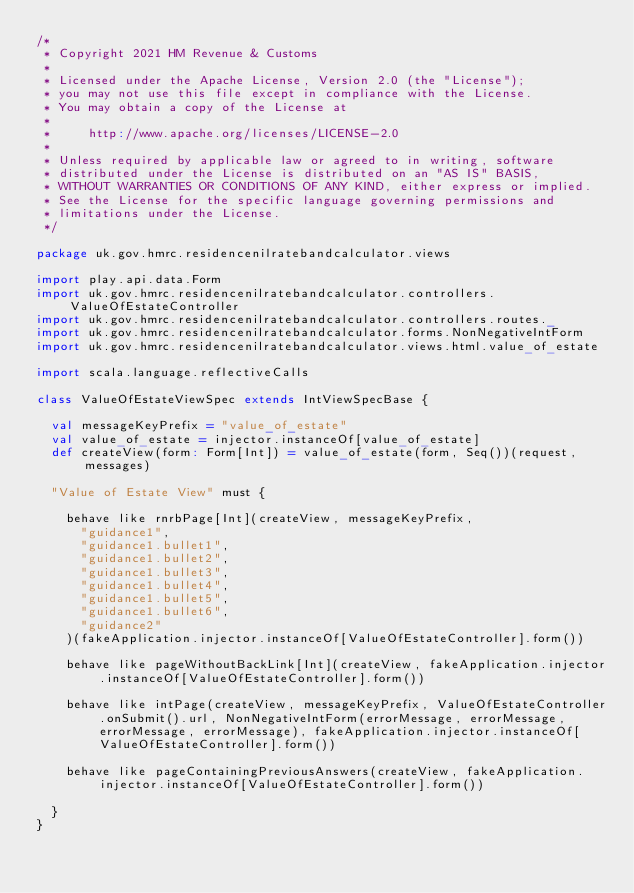Convert code to text. <code><loc_0><loc_0><loc_500><loc_500><_Scala_>/*
 * Copyright 2021 HM Revenue & Customs
 *
 * Licensed under the Apache License, Version 2.0 (the "License");
 * you may not use this file except in compliance with the License.
 * You may obtain a copy of the License at
 *
 *     http://www.apache.org/licenses/LICENSE-2.0
 *
 * Unless required by applicable law or agreed to in writing, software
 * distributed under the License is distributed on an "AS IS" BASIS,
 * WITHOUT WARRANTIES OR CONDITIONS OF ANY KIND, either express or implied.
 * See the License for the specific language governing permissions and
 * limitations under the License.
 */

package uk.gov.hmrc.residencenilratebandcalculator.views

import play.api.data.Form
import uk.gov.hmrc.residencenilratebandcalculator.controllers.ValueOfEstateController
import uk.gov.hmrc.residencenilratebandcalculator.controllers.routes._
import uk.gov.hmrc.residencenilratebandcalculator.forms.NonNegativeIntForm
import uk.gov.hmrc.residencenilratebandcalculator.views.html.value_of_estate

import scala.language.reflectiveCalls

class ValueOfEstateViewSpec extends IntViewSpecBase {

  val messageKeyPrefix = "value_of_estate"
  val value_of_estate = injector.instanceOf[value_of_estate]
  def createView(form: Form[Int]) = value_of_estate(form, Seq())(request, messages)

  "Value of Estate View" must {

    behave like rnrbPage[Int](createView, messageKeyPrefix,
      "guidance1",
      "guidance1.bullet1",
      "guidance1.bullet2",
      "guidance1.bullet3",
      "guidance1.bullet4",
      "guidance1.bullet5",
      "guidance1.bullet6",
      "guidance2"
    )(fakeApplication.injector.instanceOf[ValueOfEstateController].form())

    behave like pageWithoutBackLink[Int](createView, fakeApplication.injector.instanceOf[ValueOfEstateController].form())

    behave like intPage(createView, messageKeyPrefix, ValueOfEstateController.onSubmit().url, NonNegativeIntForm(errorMessage, errorMessage, errorMessage, errorMessage), fakeApplication.injector.instanceOf[ValueOfEstateController].form())

    behave like pageContainingPreviousAnswers(createView, fakeApplication.injector.instanceOf[ValueOfEstateController].form())

  }
}
</code> 